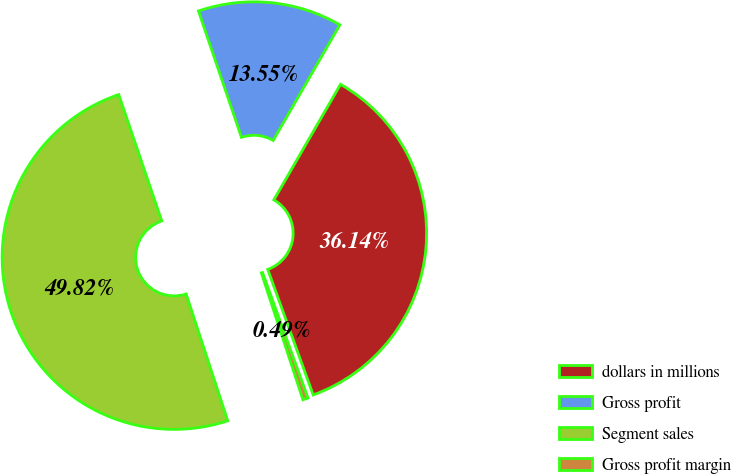Convert chart. <chart><loc_0><loc_0><loc_500><loc_500><pie_chart><fcel>dollars in millions<fcel>Gross profit<fcel>Segment sales<fcel>Gross profit margin<nl><fcel>36.14%<fcel>13.55%<fcel>49.82%<fcel>0.49%<nl></chart> 